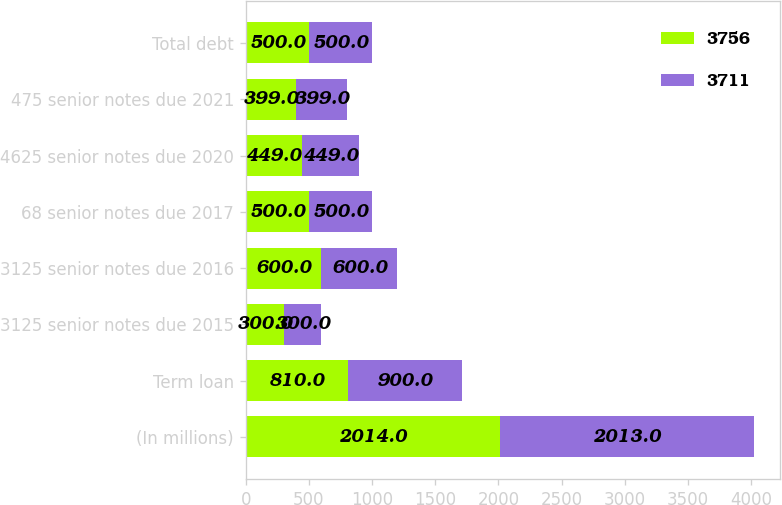<chart> <loc_0><loc_0><loc_500><loc_500><stacked_bar_chart><ecel><fcel>(In millions)<fcel>Term loan<fcel>3125 senior notes due 2015<fcel>3125 senior notes due 2016<fcel>68 senior notes due 2017<fcel>4625 senior notes due 2020<fcel>475 senior notes due 2021<fcel>Total debt<nl><fcel>3756<fcel>2014<fcel>810<fcel>300<fcel>600<fcel>500<fcel>449<fcel>399<fcel>500<nl><fcel>3711<fcel>2013<fcel>900<fcel>300<fcel>600<fcel>500<fcel>449<fcel>399<fcel>500<nl></chart> 